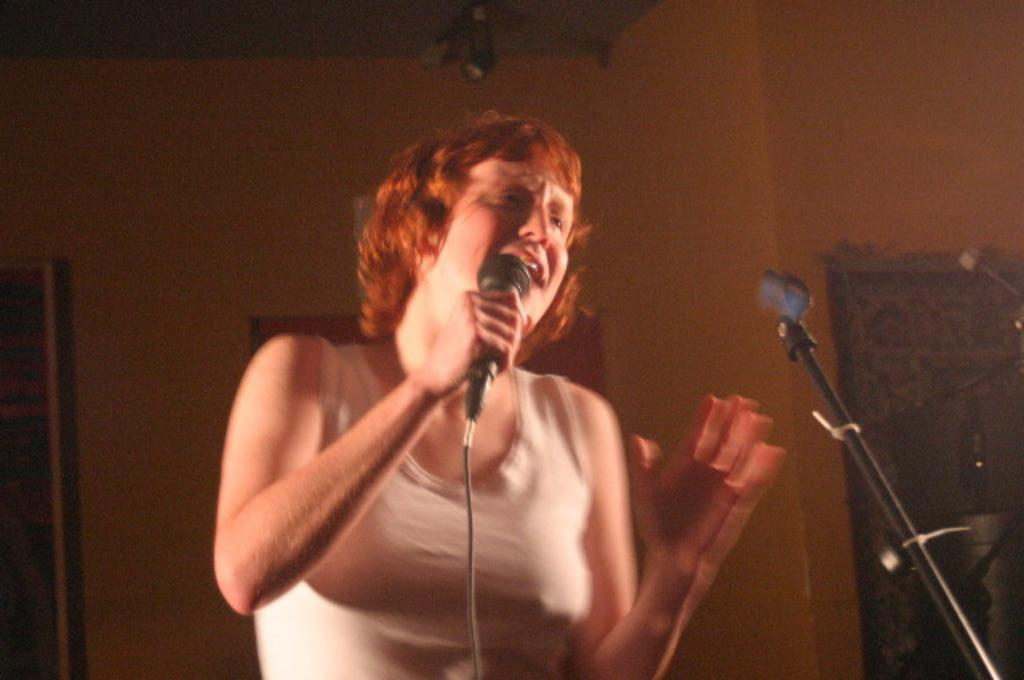What can be seen in the background of the image? There is a wall in the background of the image. Who is present in the image? There is a woman in the image. What is the woman doing in the image? The woman is standing in front of a microphone stand and singing. What is the woman holding in her hand? The woman is holding a microphone in her hand. What is the color of the woman's hair? The woman's hair color is brown. What type of property does the woman own in the image? There is no information about the woman owning any property in the image. Can you tell me how many dolls are present in the image? There are no dolls present in the image. 